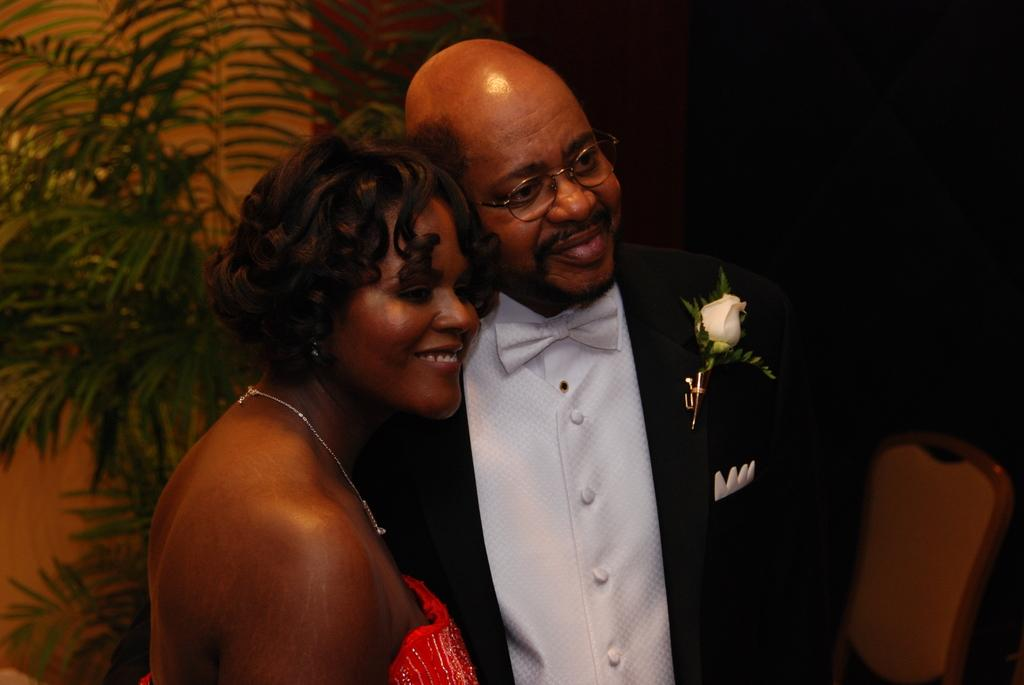Who are the people in the image? There is a man and a woman in the image. What are the man and woman doing in the image? The man and woman are standing and smiling. What can be seen in the image besides the people? There is a tree and a chair on the right side of the image. How would you describe the overall lighting in the image? The background of the image appears dark. How many children are playing with the milk in the image? There are no children or milk present in the image. What time does the clock in the image show? There are no clocks present in the image. 